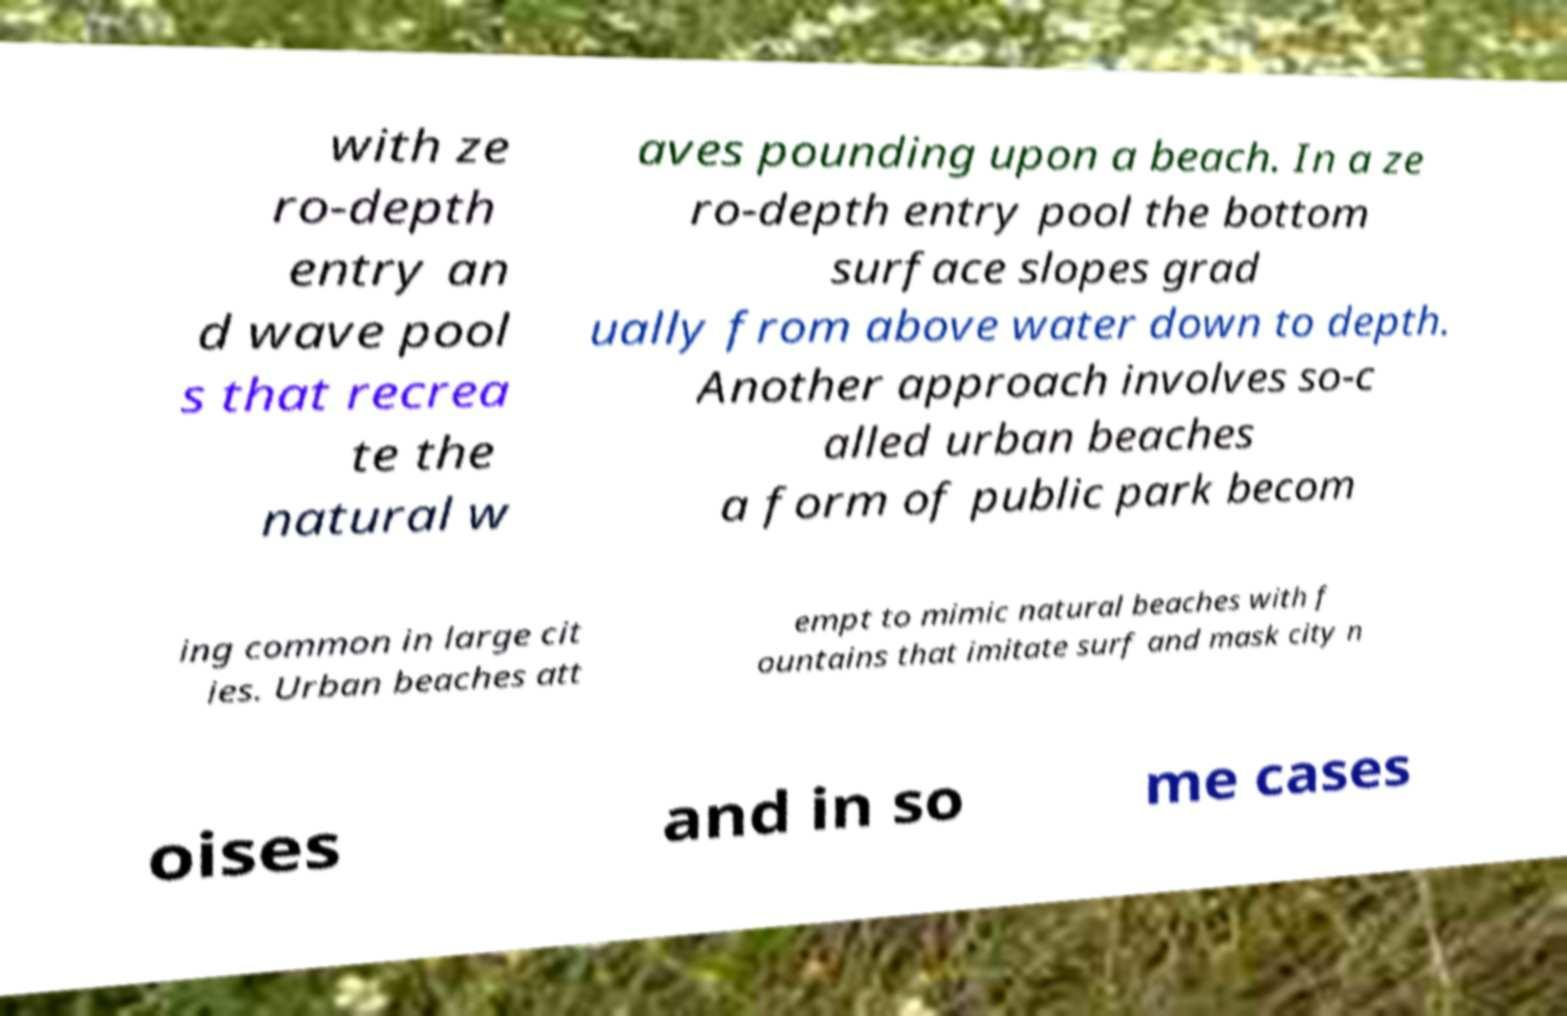Please identify and transcribe the text found in this image. with ze ro-depth entry an d wave pool s that recrea te the natural w aves pounding upon a beach. In a ze ro-depth entry pool the bottom surface slopes grad ually from above water down to depth. Another approach involves so-c alled urban beaches a form of public park becom ing common in large cit ies. Urban beaches att empt to mimic natural beaches with f ountains that imitate surf and mask city n oises and in so me cases 